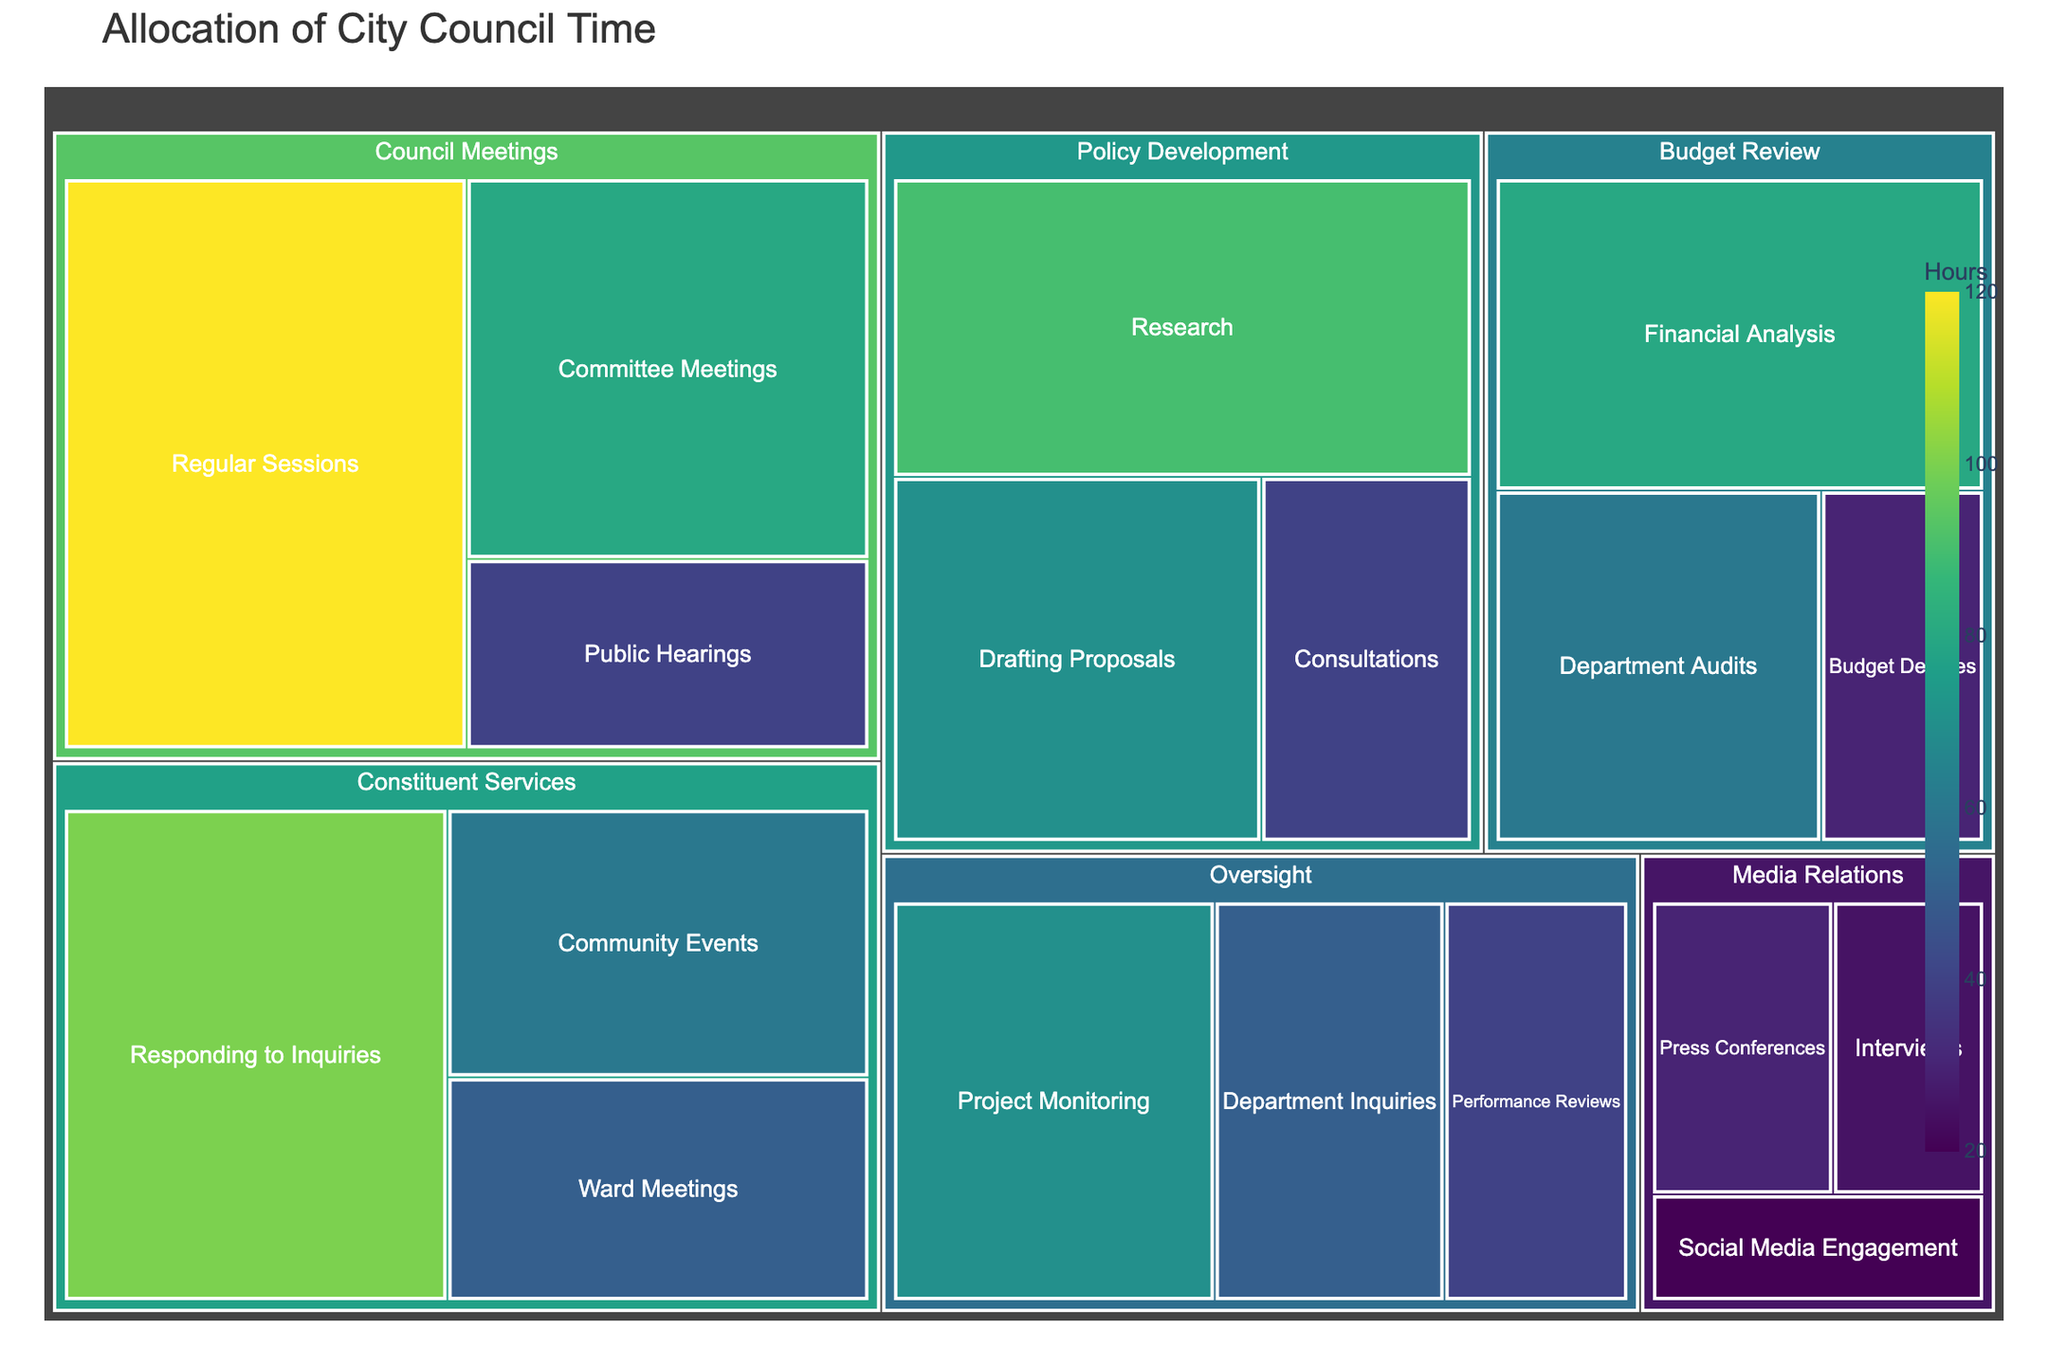What is the total number of hours spent on Council Meetings? Add the hours spent on Regular Sessions, Committee Meetings, and Public Hearings: 120 + 80 + 40 = 240 hours.
Answer: 240 hours Which subcategory has the highest number of hours? From the treemap, look for the subcategory with the largest area or darkest color, which is 'Regular Sessions' with 120 hours.
Answer: Regular Sessions How many hours are spent on Media Relations in total? Add the hours from all the subcategories under Media Relations: Press Conferences (30), Interviews (25), and Social Media Engagement (20). Total is 30 + 25 + 20 = 75 hours.
Answer: 75 hours What is the difference in hours between the highest and lowest time-consuming subcategories? The highest is Regular Sessions with 120 hours, and the lowest is Social Media Engagement with 20 hours. The difference is 120 - 20 = 100 hours.
Answer: 100 hours What percentage of the total hours is spent on Policy Development? First, calculate the total hours spent on Policy Development: Research (90) + Drafting Proposals (70) + Consultations (40) = 200 hours. Then sum all hours across categories to get the total (955 hours). The percentage is (200/955) * 100 = 20.94%.
Answer: 20.94% How many hours are spent on Constituent Services compared to Oversight? Add the hours for Constituent Services: Responding to Inquiries (100), Community Events (60), Ward Meetings (50) = 210 hours. Add the hours for Oversight: Project Monitoring (70), Department Inquiries (50), Performance Reviews (40) = 160 hours.
Answer: Constituent Services: 210 hours, Oversight: 160 hours Which category has the least number of allocated hours overall? Look for the category with the smallest total hours, which is Media Relations with 75 hours.
Answer: Media Relations What is the total number of hours spent on Budget Review? Add the hours spent on all subcategories under Budget Review: Financial Analysis (80), Department Audits (60), and Budget Debates (30). Total is 80 + 60 + 30 = 170 hours.
Answer: 170 hours How many more hours are spent on Budget Review than on Media Relations? Calculate the hours for both: Budget Review is 170 hours, Media Relations is 75 hours. The difference is 170 - 75 = 95 hours.
Answer: 95 hours 